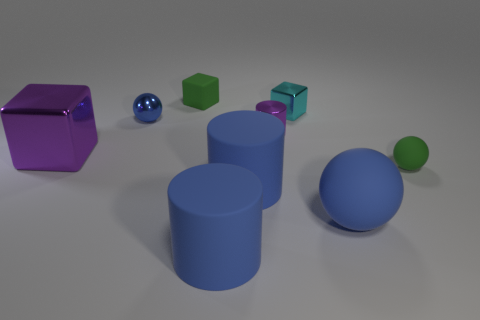There is a large object that is made of the same material as the small cyan cube; what is its shape? The large object that shares the same material characteristics as the small cyan cube is a cube as well. It appears to be a violet-colored cube, significantly larger in size compared to the small cyan one, demonstrating the diversity of shapes and sizes within this collection of geometric figures. 